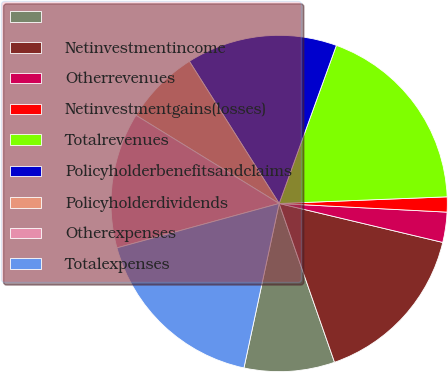<chart> <loc_0><loc_0><loc_500><loc_500><pie_chart><ecel><fcel>Netinvestmentincome<fcel>Otherrevenues<fcel>Netinvestmentgains(losses)<fcel>Totalrevenues<fcel>Policyholderbenefitsandclaims<fcel>Policyholderdividends<fcel>Otherexpenses<fcel>Totalexpenses<nl><fcel>8.7%<fcel>15.94%<fcel>2.9%<fcel>1.45%<fcel>18.84%<fcel>14.49%<fcel>7.25%<fcel>13.04%<fcel>17.39%<nl></chart> 